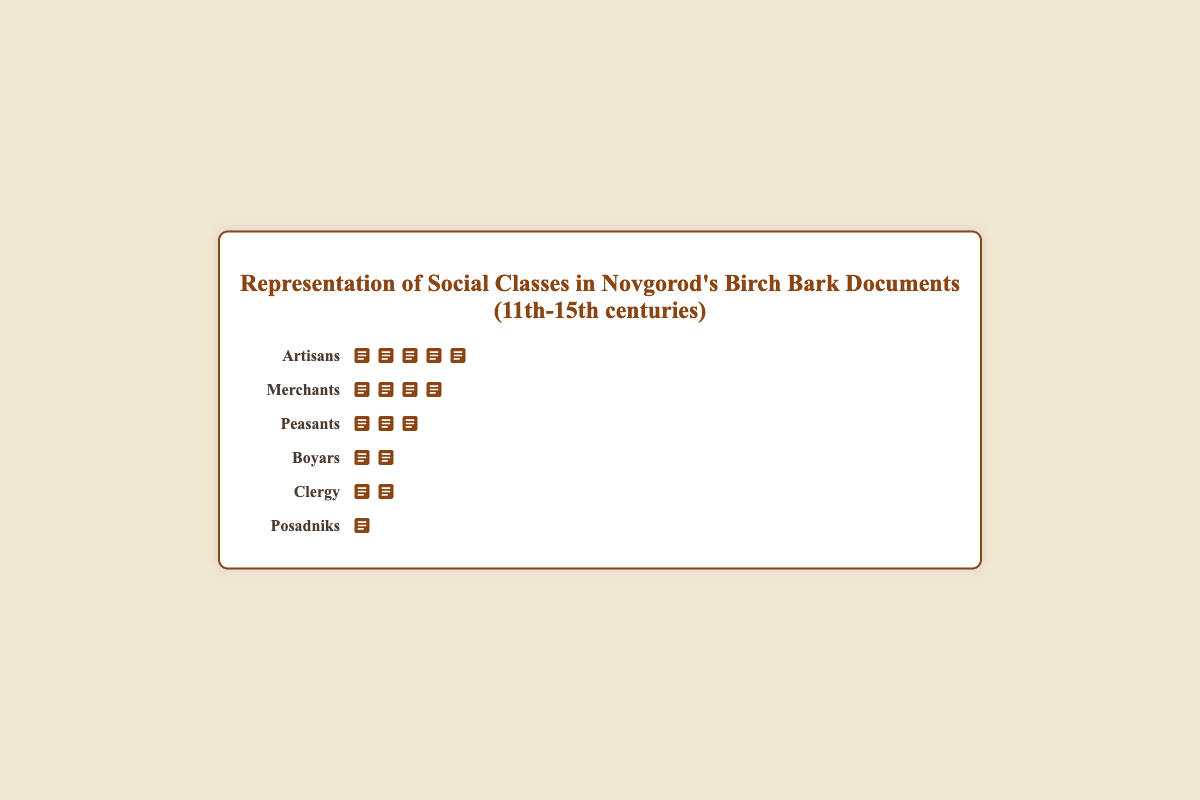How many social classes are represented in the figure? The figure lists six social classes on the y-axis, each represented by a row of icons.
Answer: 6 Which social class has the highest number of birch bark documents? By observing the length of the rows of icons, Artisans have the longest row, indicating the most documents.
Answer: Artisans Which two social classes have nearly similar numbers of birch bark documents and how many documents do they have? By comparing the lengths of the rows of icons, Boyars and Clergy have nearly similar numbers of documents. Boyars have 45 documents, and Clergy have 32 documents.
Answer: Boyars (45) and Clergy (32) What is the total number of birch bark documents represented in the figure? Adding up the documents: 45 (Boyars) + 78 (Merchants) + 32 (Clergy) + 103 (Artisans) + 57 (Peasants) + 18 (Posadniks) = 333 documents.
Answer: 333 How many more documents do Merchants have compared to Peasants? Merchants have 78 documents, and Peasants have 57 documents. The difference is 78 - 57 = 21 documents.
Answer: 21 Which social class has the least number of documents, and how many do they have? By comparing the lengths of the rows of icons, Posadniks have the shortest row, indicating the least number of documents, which is 18.
Answer: Posadniks, 18 What is the average number of documents per social class? Total number of documents is 333 across 6 social classes. The average is 333 / 6 = 55.5 documents.
Answer: 55.5 If the documents from Boyars and Posadniks are combined, how many documents are there in total? Adding the documents: 45 (Boyars) + 18 (Posadniks) = 63 documents.
Answer: 63 How does the number of documents from Artisans compare to the combined total of Boyars and Clergy? Artisans have 103 documents. Combined total of Boyars and Clergy: 45 (Boyars) + 32 (Clergy) = 77 documents. Artisans have more.
Answer: Artisans have more What percentage of the total documents are from Artisans? Artisans have 103 documents out of 333 total. The percentage is (103 / 333) * 100 ≈ 30.93%.
Answer: 30.93% 